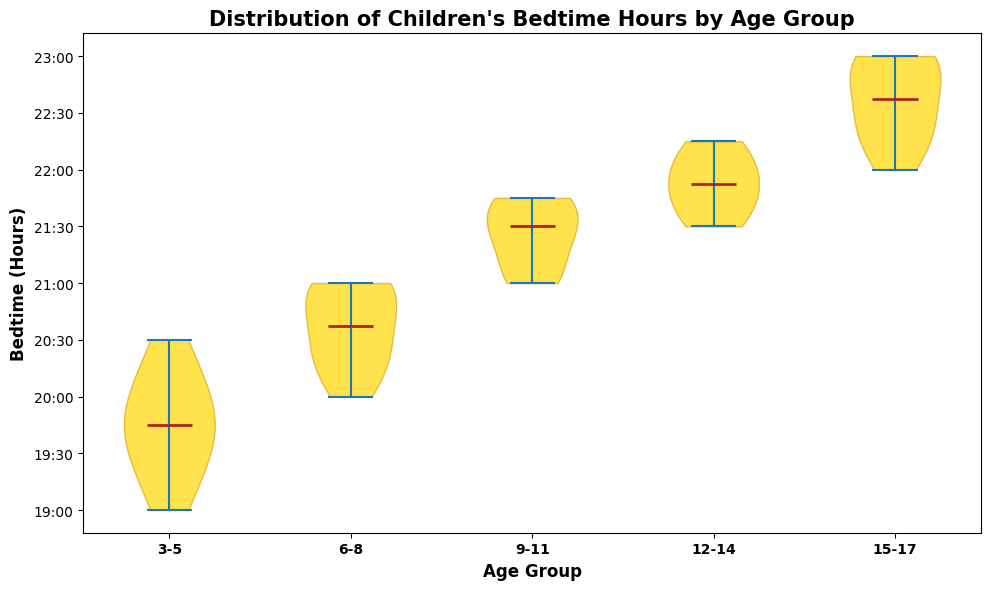Which age group goes to bed the earliest on average? Observe the median line within each violin shape. The earlier a bedtime is, the lower it will appear on the y-axis. For the earliest bedtime, you will find the median of the 3-5 age group is the lowest bedtime on the chart.
Answer: 3-5 How does the median bedtime of the 6-8 age group compare to the 9-11 age group? Look for the position of the median lines in both age groups. The 6-8 age group has a median close to 20:45, whereas the 9-11 age group has a median close to 21:30. Thus, the 6-8 age group sleeps earlier on average.
Answer: 6-8 goes to bed earlier What is the spread of bedtime hours in the 12-14 age group? The spread is the range from the lowest to the highest point of the violin. The 12-14 age group shows a range from around 21:30 to 22:15.
Answer: 21:30 to 22:15 Are the bedtimes for the 15-17 age group more spread out compared to the 3-5 age group? Notice the width and length of the violin shapes. The 15-17 age group has a wider spread ranging from 22:00 to 23:00, while the 3-5 age group ranges from 19:00 to 20:30, indicating that bedtimes for the older group are more spread out.
Answer: Yes Which age group has the latest median bedtime? Identify the highest position of the median line on the y-axis. The latest median bedtime is for the 15-17 age group, with the median close to 22:30.
Answer: 15-17 How does the range of bedtimes in the 9-11 age group compare to the 6-8 age group? Check the distance from the lowest to the highest point in the violins. The 9-11 age group ranges from around 21:00 to 21:45, and the 6-8 age group ranges from around 20:00 to 21:00. So the range of bedtime is narrower in the 9-11 age group.
Answer: Narrower in 9-11 What is the typical bedtime window for the 3-5 age group? This refers to the range where the majority of data is concentrated within the violin shape. The 3-5 age group has most bedtimes between 19:00 and 20:30.
Answer: 19:00 to 20:30 What does the height of each violin plot represent in this chart? The height of each violin plot represents the distribution of bedtime hours within that age group, showing the range from the earliest to the latest bedtime.
Answer: Bedtime hours distribution Do the bedtimes become later as the age group increases? By observing the position of each median line across age groups, we see a clear upward trend in medians, confirming that bedtimes become increasingly later with age.
Answer: Yes 